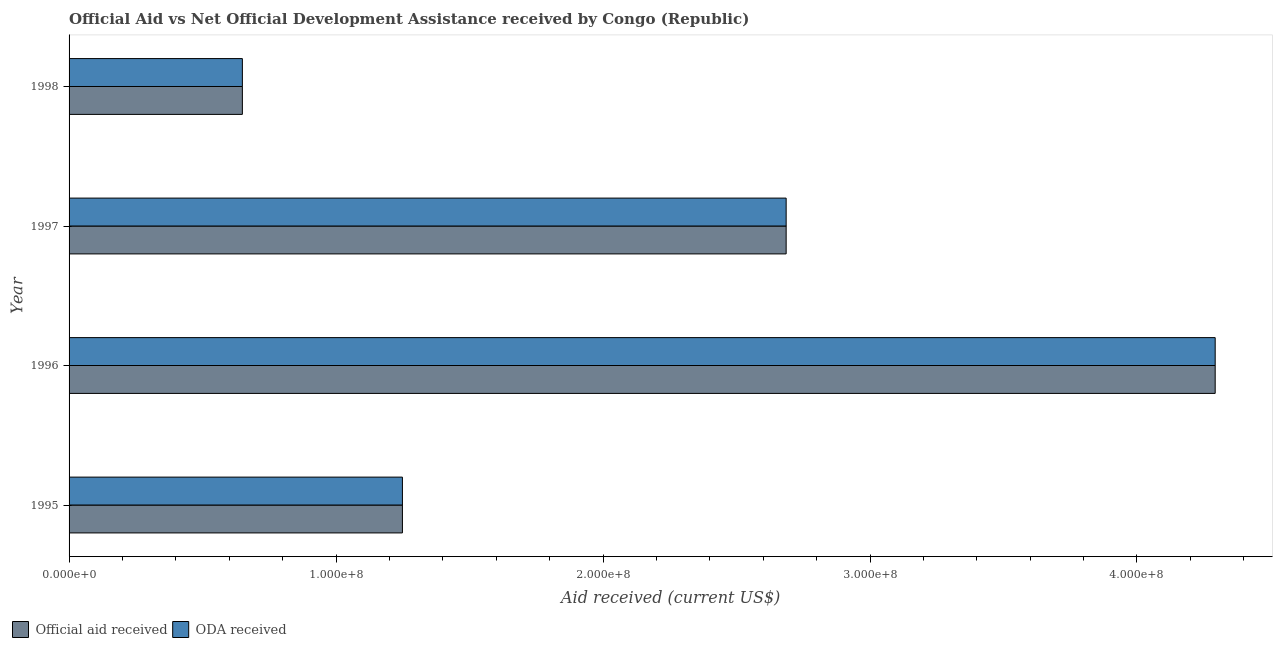How many different coloured bars are there?
Offer a terse response. 2. How many groups of bars are there?
Provide a short and direct response. 4. Are the number of bars on each tick of the Y-axis equal?
Your answer should be very brief. Yes. What is the label of the 4th group of bars from the top?
Make the answer very short. 1995. In how many cases, is the number of bars for a given year not equal to the number of legend labels?
Make the answer very short. 0. What is the oda received in 1996?
Your answer should be very brief. 4.29e+08. Across all years, what is the maximum official aid received?
Ensure brevity in your answer.  4.29e+08. Across all years, what is the minimum oda received?
Give a very brief answer. 6.49e+07. In which year was the oda received minimum?
Provide a succinct answer. 1998. What is the total official aid received in the graph?
Ensure brevity in your answer.  8.88e+08. What is the difference between the oda received in 1995 and that in 1996?
Offer a very short reply. -3.04e+08. What is the difference between the official aid received in 1995 and the oda received in 1996?
Offer a very short reply. -3.04e+08. What is the average oda received per year?
Offer a very short reply. 2.22e+08. What is the ratio of the official aid received in 1996 to that in 1997?
Your response must be concise. 1.6. What is the difference between the highest and the second highest oda received?
Give a very brief answer. 1.61e+08. What is the difference between the highest and the lowest oda received?
Provide a short and direct response. 3.64e+08. In how many years, is the official aid received greater than the average official aid received taken over all years?
Your answer should be very brief. 2. Is the sum of the official aid received in 1996 and 1998 greater than the maximum oda received across all years?
Your answer should be very brief. Yes. What does the 1st bar from the top in 1996 represents?
Ensure brevity in your answer.  ODA received. What does the 1st bar from the bottom in 1997 represents?
Keep it short and to the point. Official aid received. Are all the bars in the graph horizontal?
Keep it short and to the point. Yes. How many years are there in the graph?
Ensure brevity in your answer.  4. Are the values on the major ticks of X-axis written in scientific E-notation?
Your answer should be very brief. Yes. Where does the legend appear in the graph?
Give a very brief answer. Bottom left. How are the legend labels stacked?
Your answer should be very brief. Horizontal. What is the title of the graph?
Offer a very short reply. Official Aid vs Net Official Development Assistance received by Congo (Republic) . What is the label or title of the X-axis?
Your answer should be very brief. Aid received (current US$). What is the Aid received (current US$) in Official aid received in 1995?
Provide a short and direct response. 1.25e+08. What is the Aid received (current US$) in ODA received in 1995?
Keep it short and to the point. 1.25e+08. What is the Aid received (current US$) of Official aid received in 1996?
Ensure brevity in your answer.  4.29e+08. What is the Aid received (current US$) in ODA received in 1996?
Provide a succinct answer. 4.29e+08. What is the Aid received (current US$) of Official aid received in 1997?
Provide a short and direct response. 2.69e+08. What is the Aid received (current US$) in ODA received in 1997?
Provide a succinct answer. 2.69e+08. What is the Aid received (current US$) of Official aid received in 1998?
Your answer should be compact. 6.49e+07. What is the Aid received (current US$) in ODA received in 1998?
Ensure brevity in your answer.  6.49e+07. Across all years, what is the maximum Aid received (current US$) in Official aid received?
Your response must be concise. 4.29e+08. Across all years, what is the maximum Aid received (current US$) of ODA received?
Provide a succinct answer. 4.29e+08. Across all years, what is the minimum Aid received (current US$) of Official aid received?
Your answer should be compact. 6.49e+07. Across all years, what is the minimum Aid received (current US$) of ODA received?
Provide a short and direct response. 6.49e+07. What is the total Aid received (current US$) of Official aid received in the graph?
Provide a short and direct response. 8.88e+08. What is the total Aid received (current US$) in ODA received in the graph?
Keep it short and to the point. 8.88e+08. What is the difference between the Aid received (current US$) of Official aid received in 1995 and that in 1996?
Offer a terse response. -3.04e+08. What is the difference between the Aid received (current US$) of ODA received in 1995 and that in 1996?
Offer a very short reply. -3.04e+08. What is the difference between the Aid received (current US$) in Official aid received in 1995 and that in 1997?
Keep it short and to the point. -1.44e+08. What is the difference between the Aid received (current US$) of ODA received in 1995 and that in 1997?
Keep it short and to the point. -1.44e+08. What is the difference between the Aid received (current US$) of Official aid received in 1995 and that in 1998?
Your response must be concise. 6.00e+07. What is the difference between the Aid received (current US$) in ODA received in 1995 and that in 1998?
Make the answer very short. 6.00e+07. What is the difference between the Aid received (current US$) of Official aid received in 1996 and that in 1997?
Ensure brevity in your answer.  1.61e+08. What is the difference between the Aid received (current US$) in ODA received in 1996 and that in 1997?
Your answer should be compact. 1.61e+08. What is the difference between the Aid received (current US$) in Official aid received in 1996 and that in 1998?
Provide a succinct answer. 3.64e+08. What is the difference between the Aid received (current US$) in ODA received in 1996 and that in 1998?
Your response must be concise. 3.64e+08. What is the difference between the Aid received (current US$) of Official aid received in 1997 and that in 1998?
Offer a terse response. 2.04e+08. What is the difference between the Aid received (current US$) of ODA received in 1997 and that in 1998?
Provide a succinct answer. 2.04e+08. What is the difference between the Aid received (current US$) in Official aid received in 1995 and the Aid received (current US$) in ODA received in 1996?
Make the answer very short. -3.04e+08. What is the difference between the Aid received (current US$) of Official aid received in 1995 and the Aid received (current US$) of ODA received in 1997?
Your answer should be very brief. -1.44e+08. What is the difference between the Aid received (current US$) of Official aid received in 1995 and the Aid received (current US$) of ODA received in 1998?
Your response must be concise. 6.00e+07. What is the difference between the Aid received (current US$) in Official aid received in 1996 and the Aid received (current US$) in ODA received in 1997?
Provide a succinct answer. 1.61e+08. What is the difference between the Aid received (current US$) of Official aid received in 1996 and the Aid received (current US$) of ODA received in 1998?
Keep it short and to the point. 3.64e+08. What is the difference between the Aid received (current US$) of Official aid received in 1997 and the Aid received (current US$) of ODA received in 1998?
Your answer should be compact. 2.04e+08. What is the average Aid received (current US$) of Official aid received per year?
Your response must be concise. 2.22e+08. What is the average Aid received (current US$) of ODA received per year?
Give a very brief answer. 2.22e+08. In the year 1997, what is the difference between the Aid received (current US$) of Official aid received and Aid received (current US$) of ODA received?
Your answer should be very brief. 0. In the year 1998, what is the difference between the Aid received (current US$) in Official aid received and Aid received (current US$) in ODA received?
Give a very brief answer. 0. What is the ratio of the Aid received (current US$) of Official aid received in 1995 to that in 1996?
Offer a very short reply. 0.29. What is the ratio of the Aid received (current US$) of ODA received in 1995 to that in 1996?
Ensure brevity in your answer.  0.29. What is the ratio of the Aid received (current US$) in Official aid received in 1995 to that in 1997?
Offer a terse response. 0.46. What is the ratio of the Aid received (current US$) of ODA received in 1995 to that in 1997?
Give a very brief answer. 0.46. What is the ratio of the Aid received (current US$) in Official aid received in 1995 to that in 1998?
Offer a terse response. 1.92. What is the ratio of the Aid received (current US$) of ODA received in 1995 to that in 1998?
Offer a very short reply. 1.92. What is the ratio of the Aid received (current US$) of Official aid received in 1996 to that in 1997?
Ensure brevity in your answer.  1.6. What is the ratio of the Aid received (current US$) in ODA received in 1996 to that in 1997?
Your answer should be compact. 1.6. What is the ratio of the Aid received (current US$) in Official aid received in 1996 to that in 1998?
Ensure brevity in your answer.  6.61. What is the ratio of the Aid received (current US$) of ODA received in 1996 to that in 1998?
Offer a very short reply. 6.61. What is the ratio of the Aid received (current US$) in Official aid received in 1997 to that in 1998?
Ensure brevity in your answer.  4.14. What is the ratio of the Aid received (current US$) of ODA received in 1997 to that in 1998?
Your answer should be very brief. 4.14. What is the difference between the highest and the second highest Aid received (current US$) of Official aid received?
Your answer should be very brief. 1.61e+08. What is the difference between the highest and the second highest Aid received (current US$) of ODA received?
Your response must be concise. 1.61e+08. What is the difference between the highest and the lowest Aid received (current US$) in Official aid received?
Ensure brevity in your answer.  3.64e+08. What is the difference between the highest and the lowest Aid received (current US$) of ODA received?
Provide a short and direct response. 3.64e+08. 